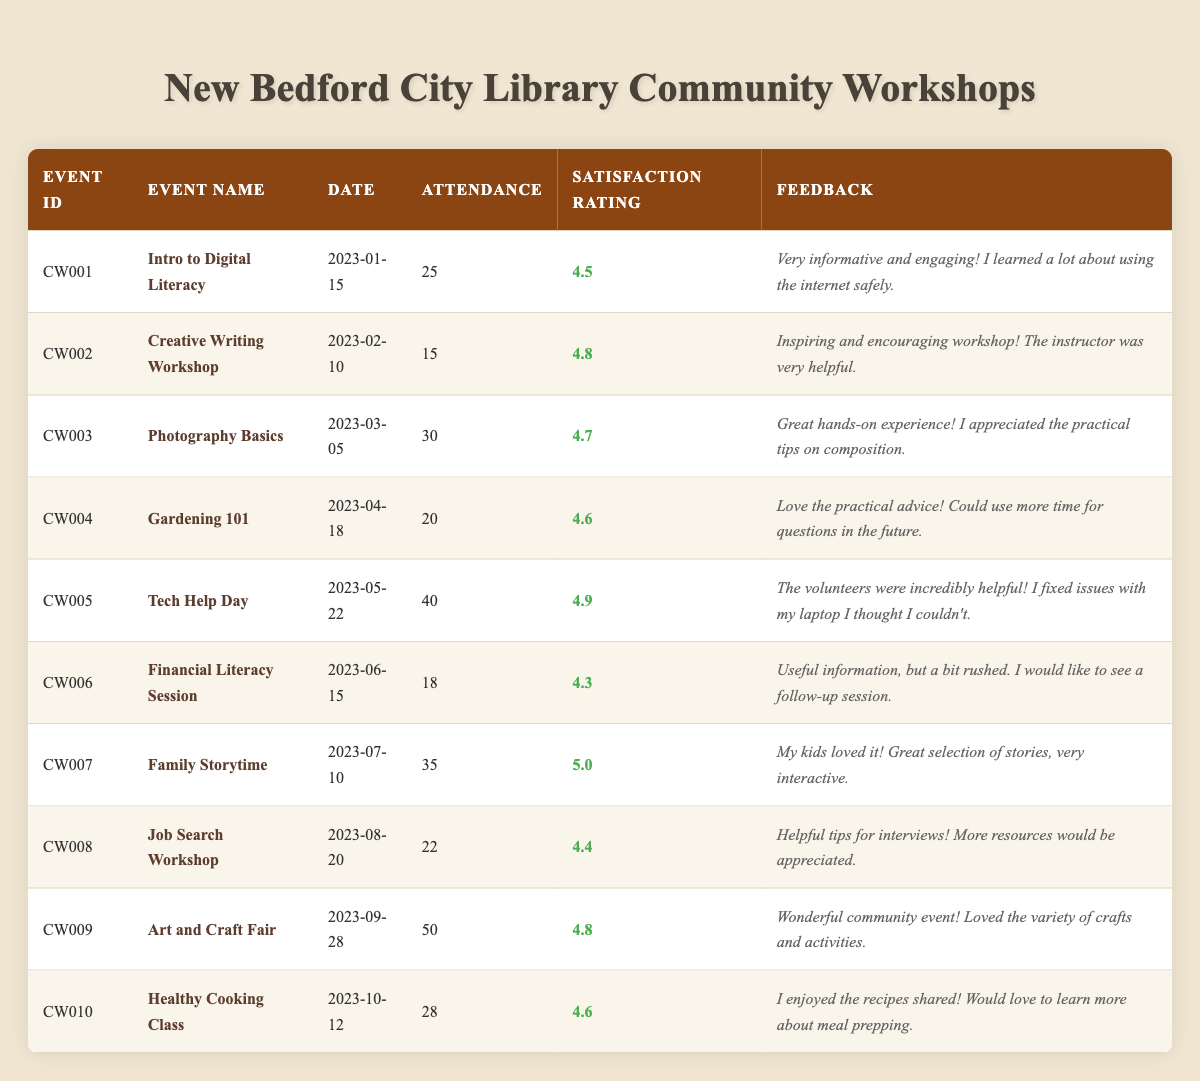What was the event with the highest attendance? By checking the attendance column, the event with the highest attendance recorded is the "Art and Craft Fair" with an attendance of 50.
Answer: Art and Craft Fair What is the satisfaction rating of the "Tech Help Day"? Looking at the satisfaction rating column for the "Tech Help Day" event, it shows a rating of 4.9.
Answer: 4.9 How many workshops had an attendance of over 25 participants? The events are examined one by one. "Tech Help Day" (40), "Photography Basics" (30), "Family Storytime" (35), and "Art and Craft Fair" (50) all exceed 25. That gives us a total of 4 workshops.
Answer: 4 Which event received the lowest satisfaction rating? Reviewing the satisfaction rating column, the "Financial Literacy Session" has the lowest satisfaction rating of 4.3 compared to others.
Answer: 4.3 Did the "Creative Writing Workshop" have a higher satisfaction rating than the "Job Search Workshop"? Comparing the satisfaction ratings, the rating for "Creative Writing Workshop" is 4.8 and for "Job Search Workshop" it is 4.4. Since 4.8 is greater than 4.4, the statement is true.
Answer: Yes What was the average attendance across all workshops? To calculate the average, first sum the attendance numbers: 25 + 15 + 30 + 20 + 40 + 18 + 35 + 22 + 50 + 28 =  318. Then divide by the number of workshops, which is 10: 318 / 10 = 31.8.
Answer: 31.8 Was there any event that received a satisfaction rating of 5.0? Checking the satisfaction ratings, the "Family Storytime" received a perfect score of 5.0. Thus, the answer is yes.
Answer: Yes How many events focused on practical skills like technology or cooking? The events that focus on practical skills are "Tech Help Day" (technology) and "Healthy Cooking Class" (cooking). Therefore, there are 2 such events in total.
Answer: 2 